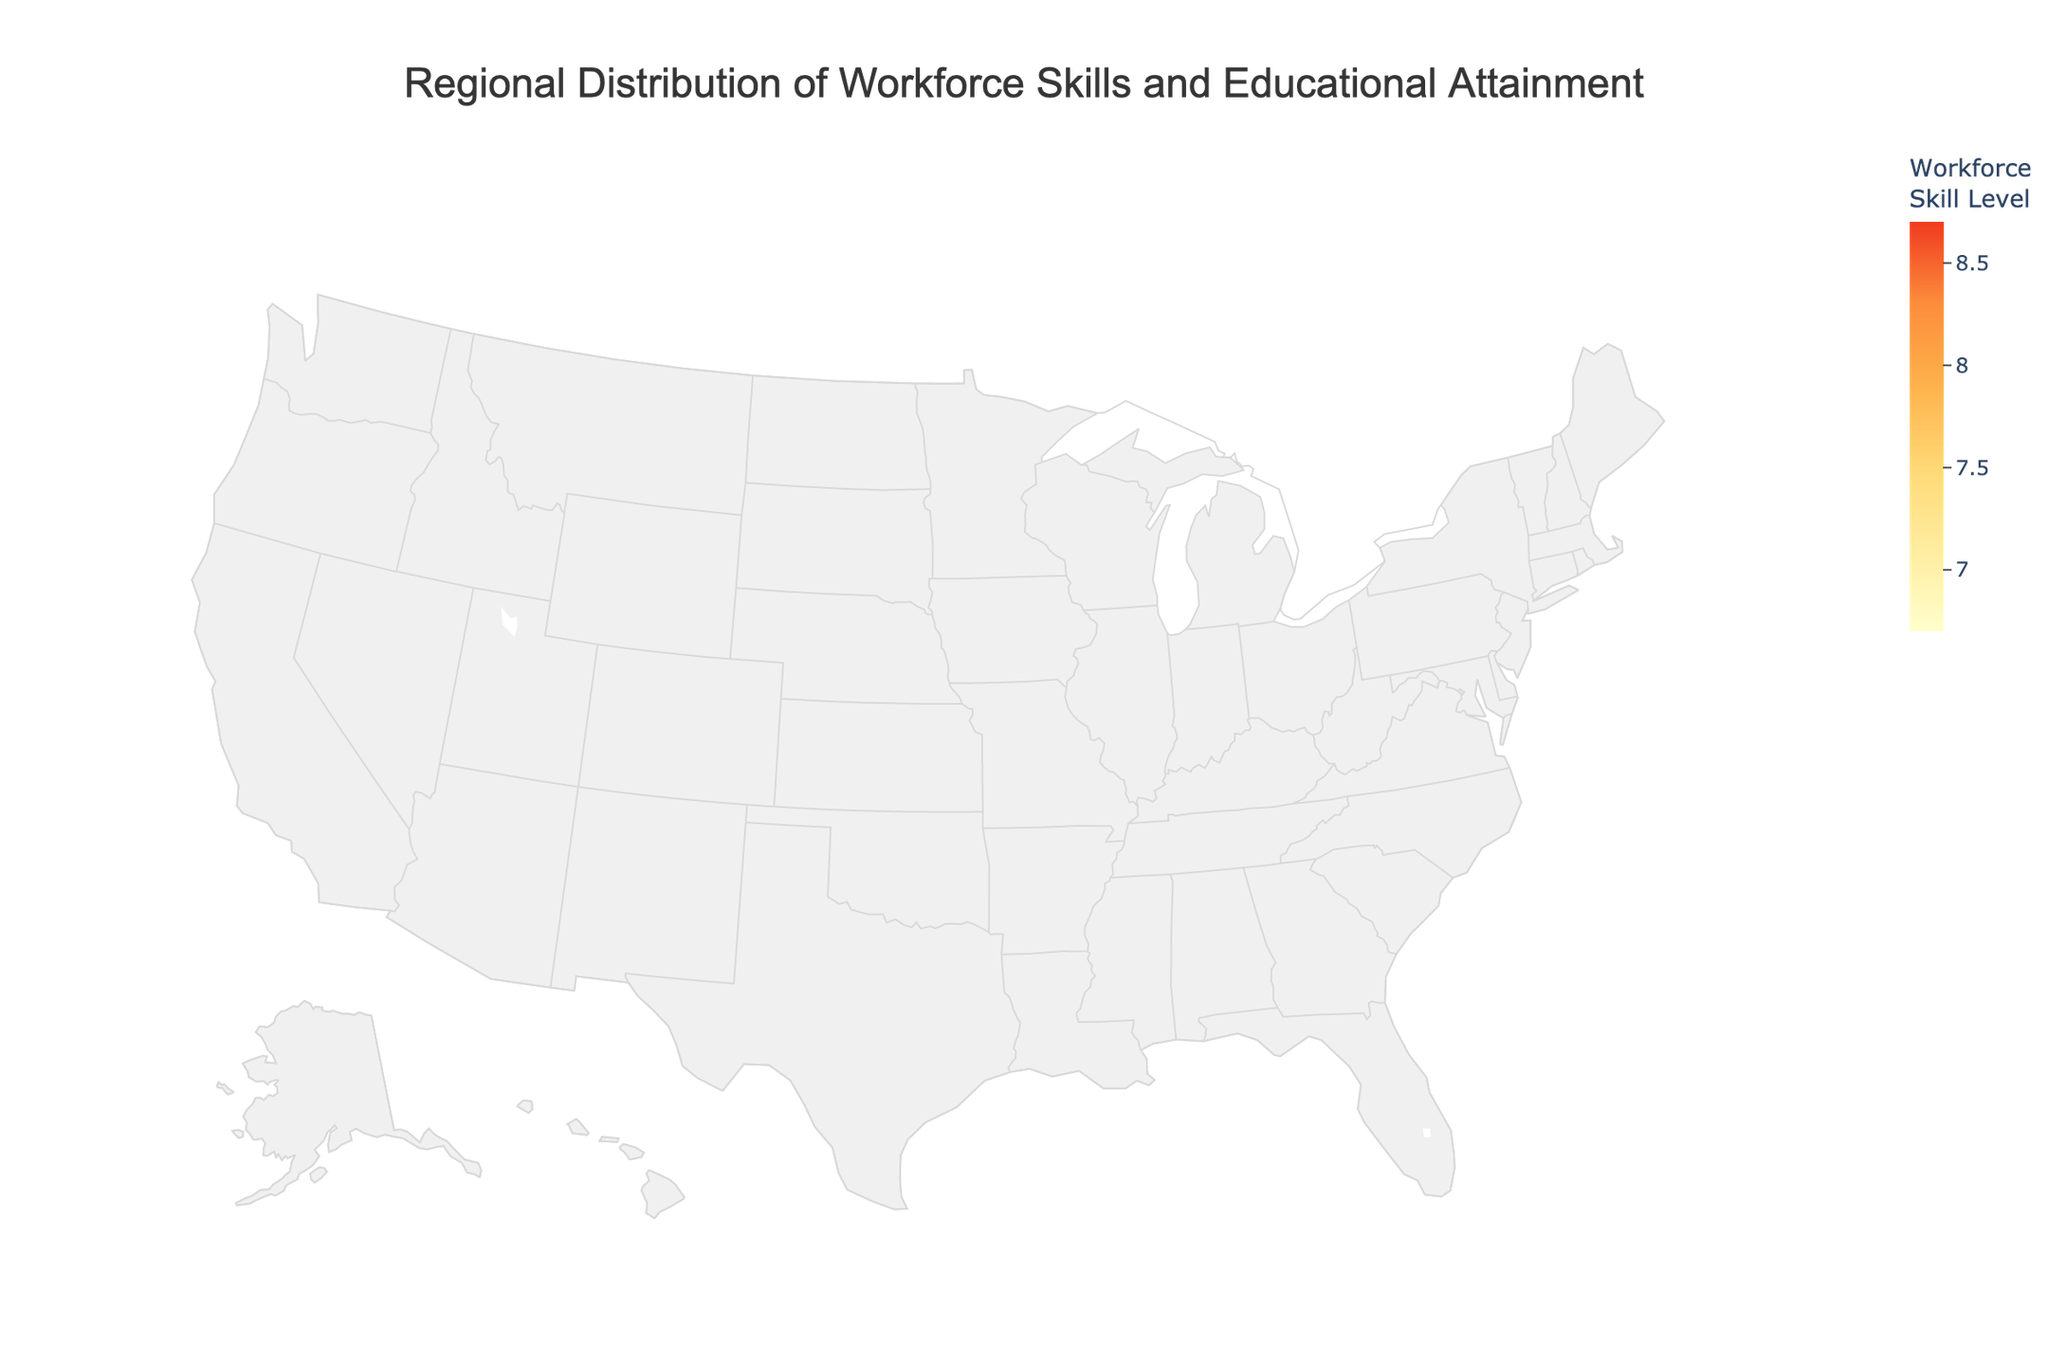What is the title of the figure? The title is usually displayed at the top of the figure within the layout settings. Here, it says "Regional Distribution of Workforce Skills and Educational Attainment."
Answer: Regional Distribution of Workforce Skills and Educational Attainment Which region has the highest workforce skill level? Look at the color-coded bubbles representing workforce skill levels. San Francisco has the darkest shade, indicating the highest skill level.
Answer: San Francisco What is the educational attainment level in Los Angeles? By checking the annotations or the hover data for Los Angeles, you'll see the educational attainment level mentioned.
Answer: Some college Which region has the largest population? The size of the bubble indicates population size. The largest bubble is New York City.
Answer: New York City How does the workforce skill level of Chicago compare to Phoenix? Compare the colors of the bubbles. Chicago's bubble is darker than Phoenix's, indicating a higher workforce skill level.
Answer: Chicago has a higher workforce skill level What's the average workforce skill level of regions with a Bachelor's degree or higher? Sum the workforce skill levels for regions with a Bachelor's degree or higher (New York City, Chicago, Philadelphia, San Diego, San Jose, Austin, Columbus, San Francisco), then divide by the number of such regions. (8.2 + 7.8 + 7.6 + 7.9 + 8.5 + 8.1 + 7.7 + 8.7) / 8 = 8.06.
Answer: 8.06 How many regions have 'Some college' as their educational attainment level? The figure annotations indicate educational attainment. Count the regions with 'Some college': Los Angeles, Phoenix, Dallas, Jacksonville (4 regions).
Answer: 4 Which regions have a workforce skill level lower than 7? Check the bubble colors and annotations. Houston, San Antonio, and Fort Worth have skill levels below 7.
Answer: Houston, San Antonio, Fort Worth What is the total population of regions with 'High school diploma' educational attainment? Add the populations for the regions with 'High school diploma' (Houston, San Antonio, Fort Worth). 2304000 + 1547000 + 909585 = 4760585.
Answer: 4,760,585 Which region has the smallest population, and what is its educational attainment level? The smallest bubble represents San Jose, and its educational attainment level is Bachelor's or higher.
Answer: San Jose, Bachelor's or higher 